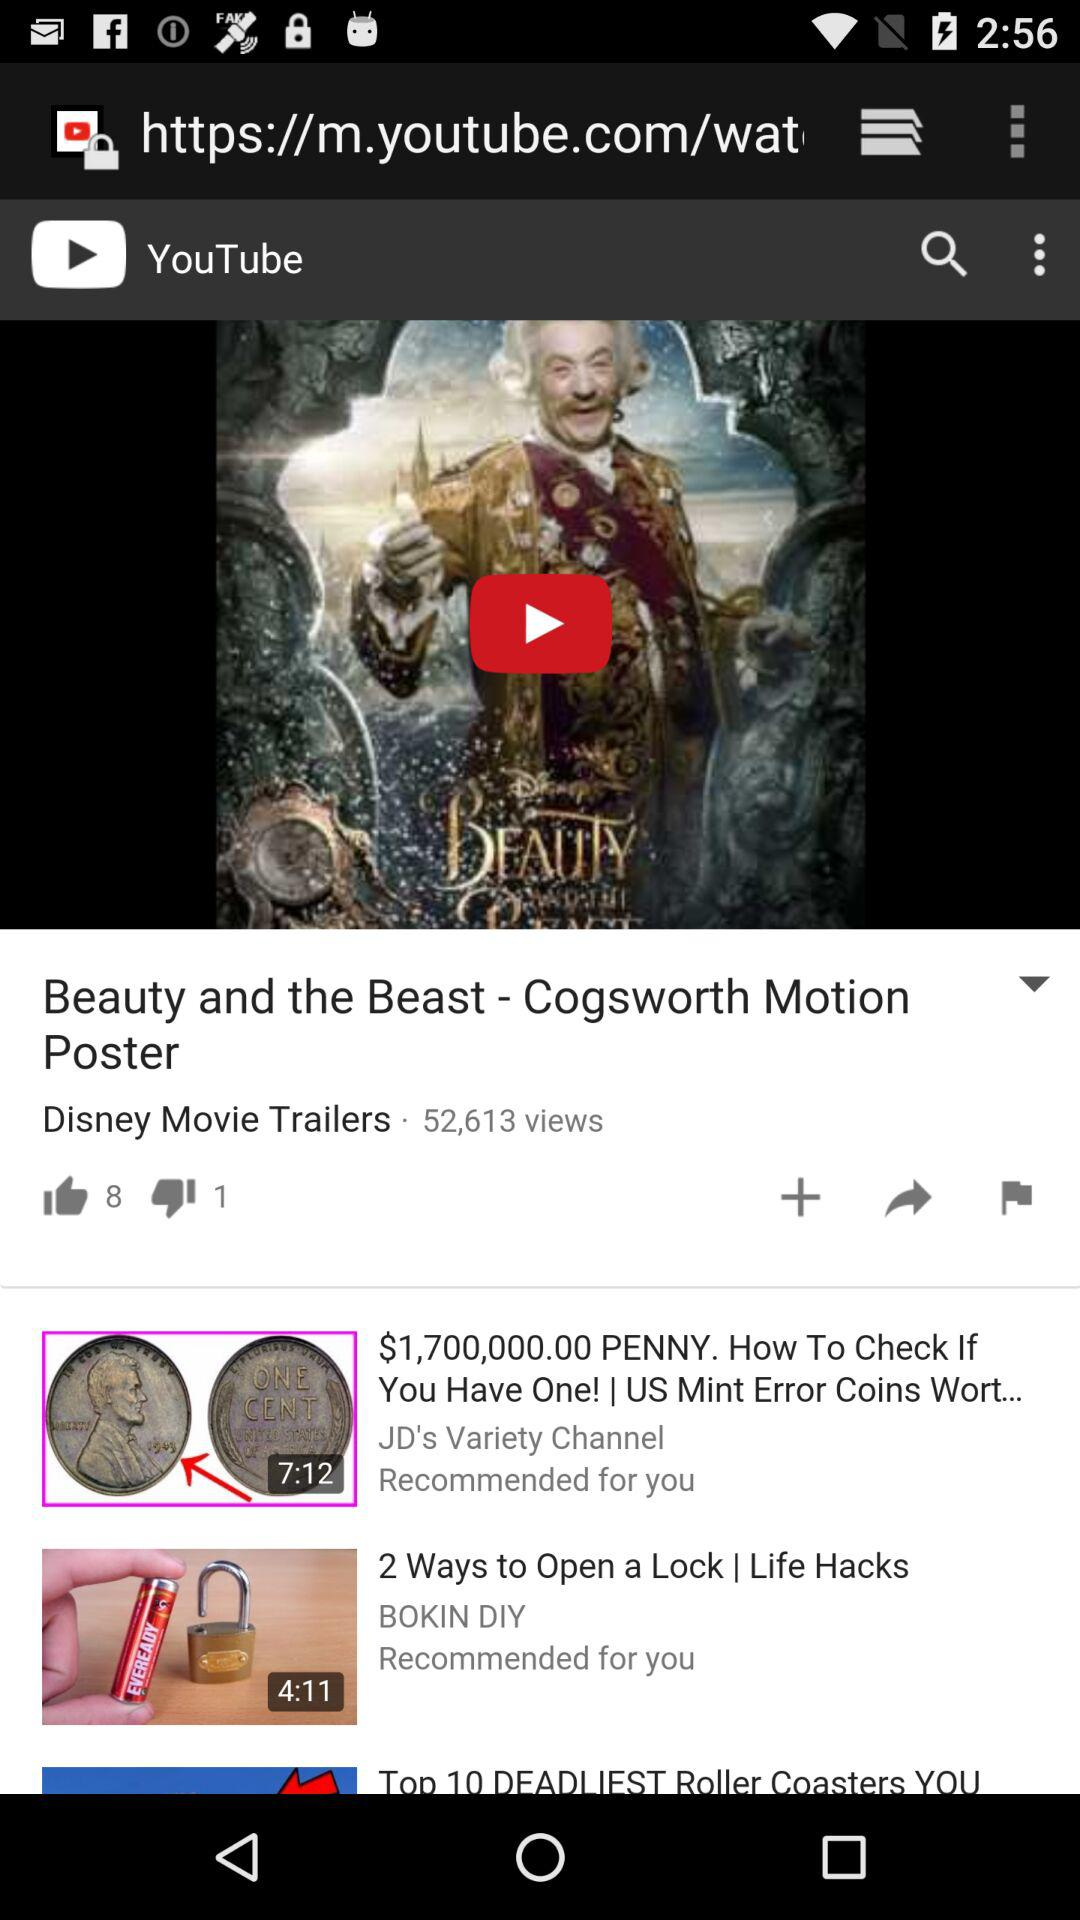What is the name of the application? The name of the application is "YouTube". 